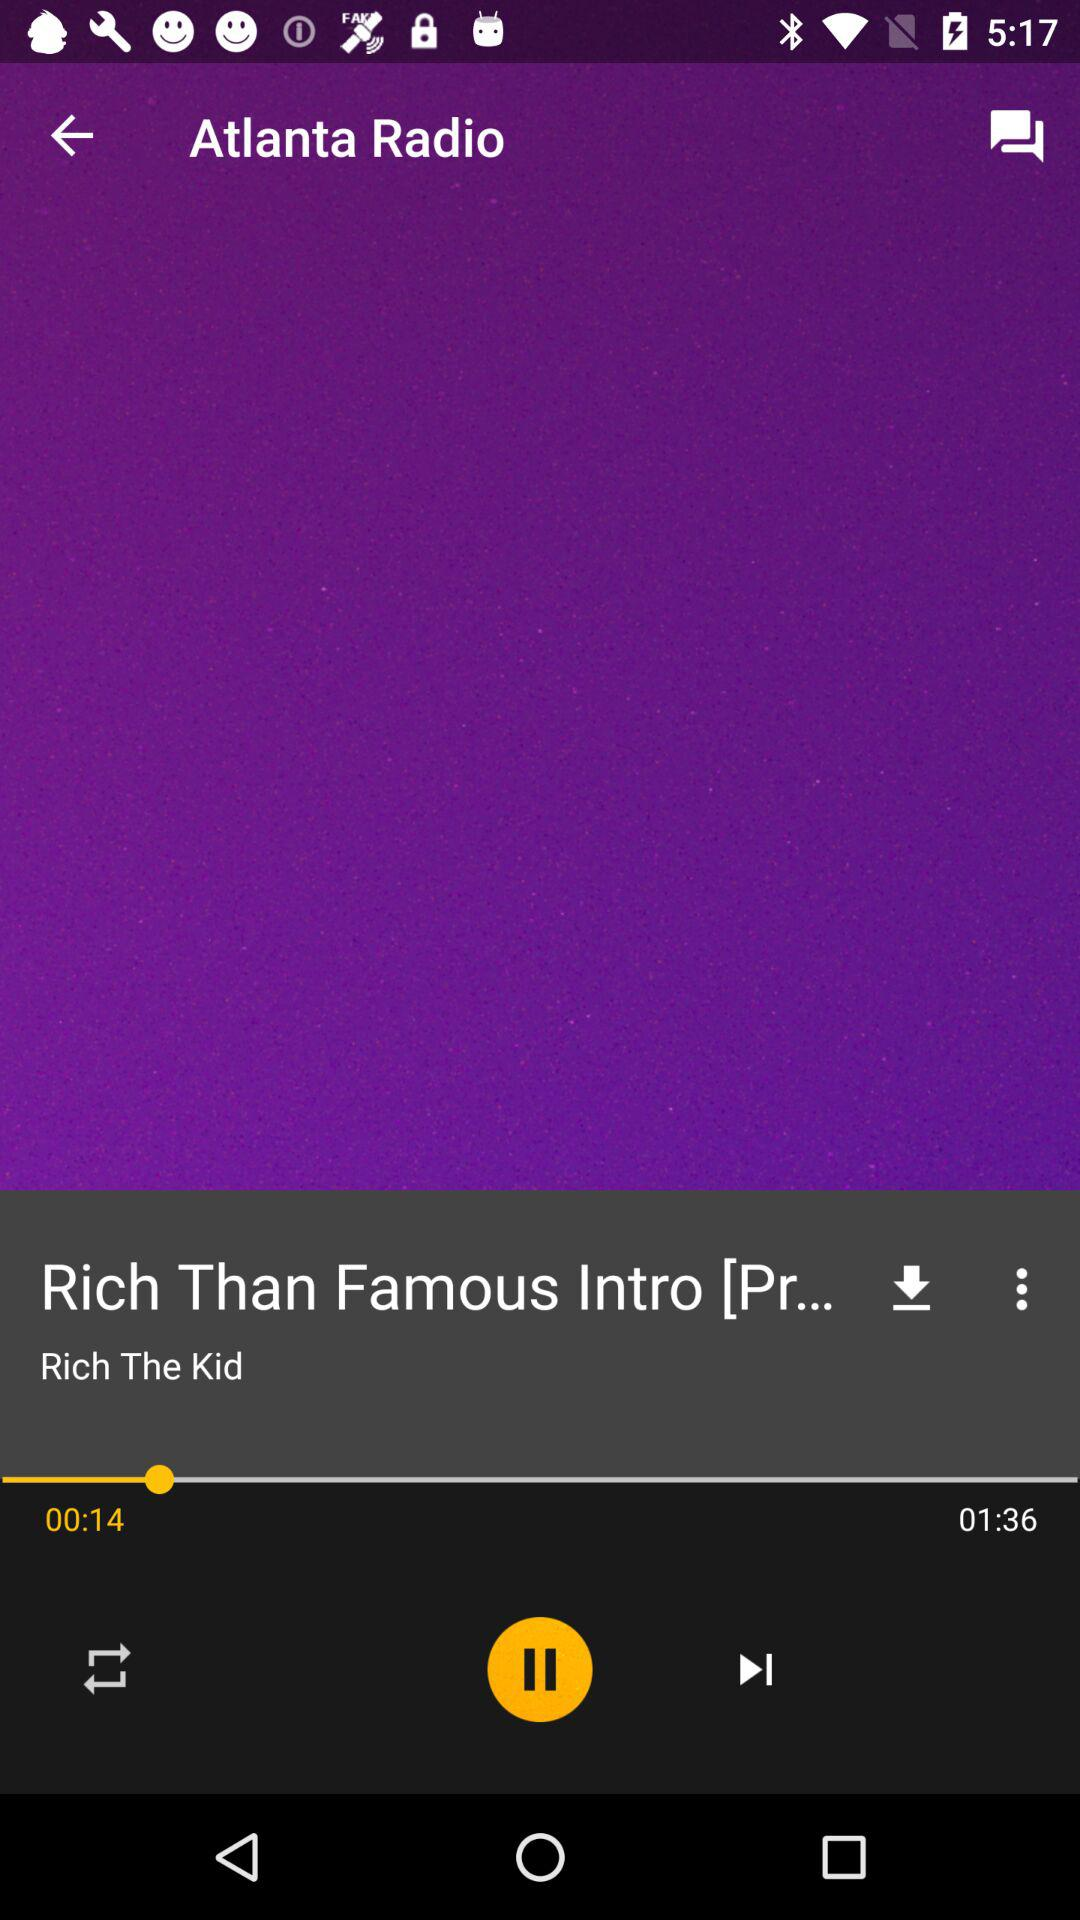What is the radio name? The radio name is Atlanta. 